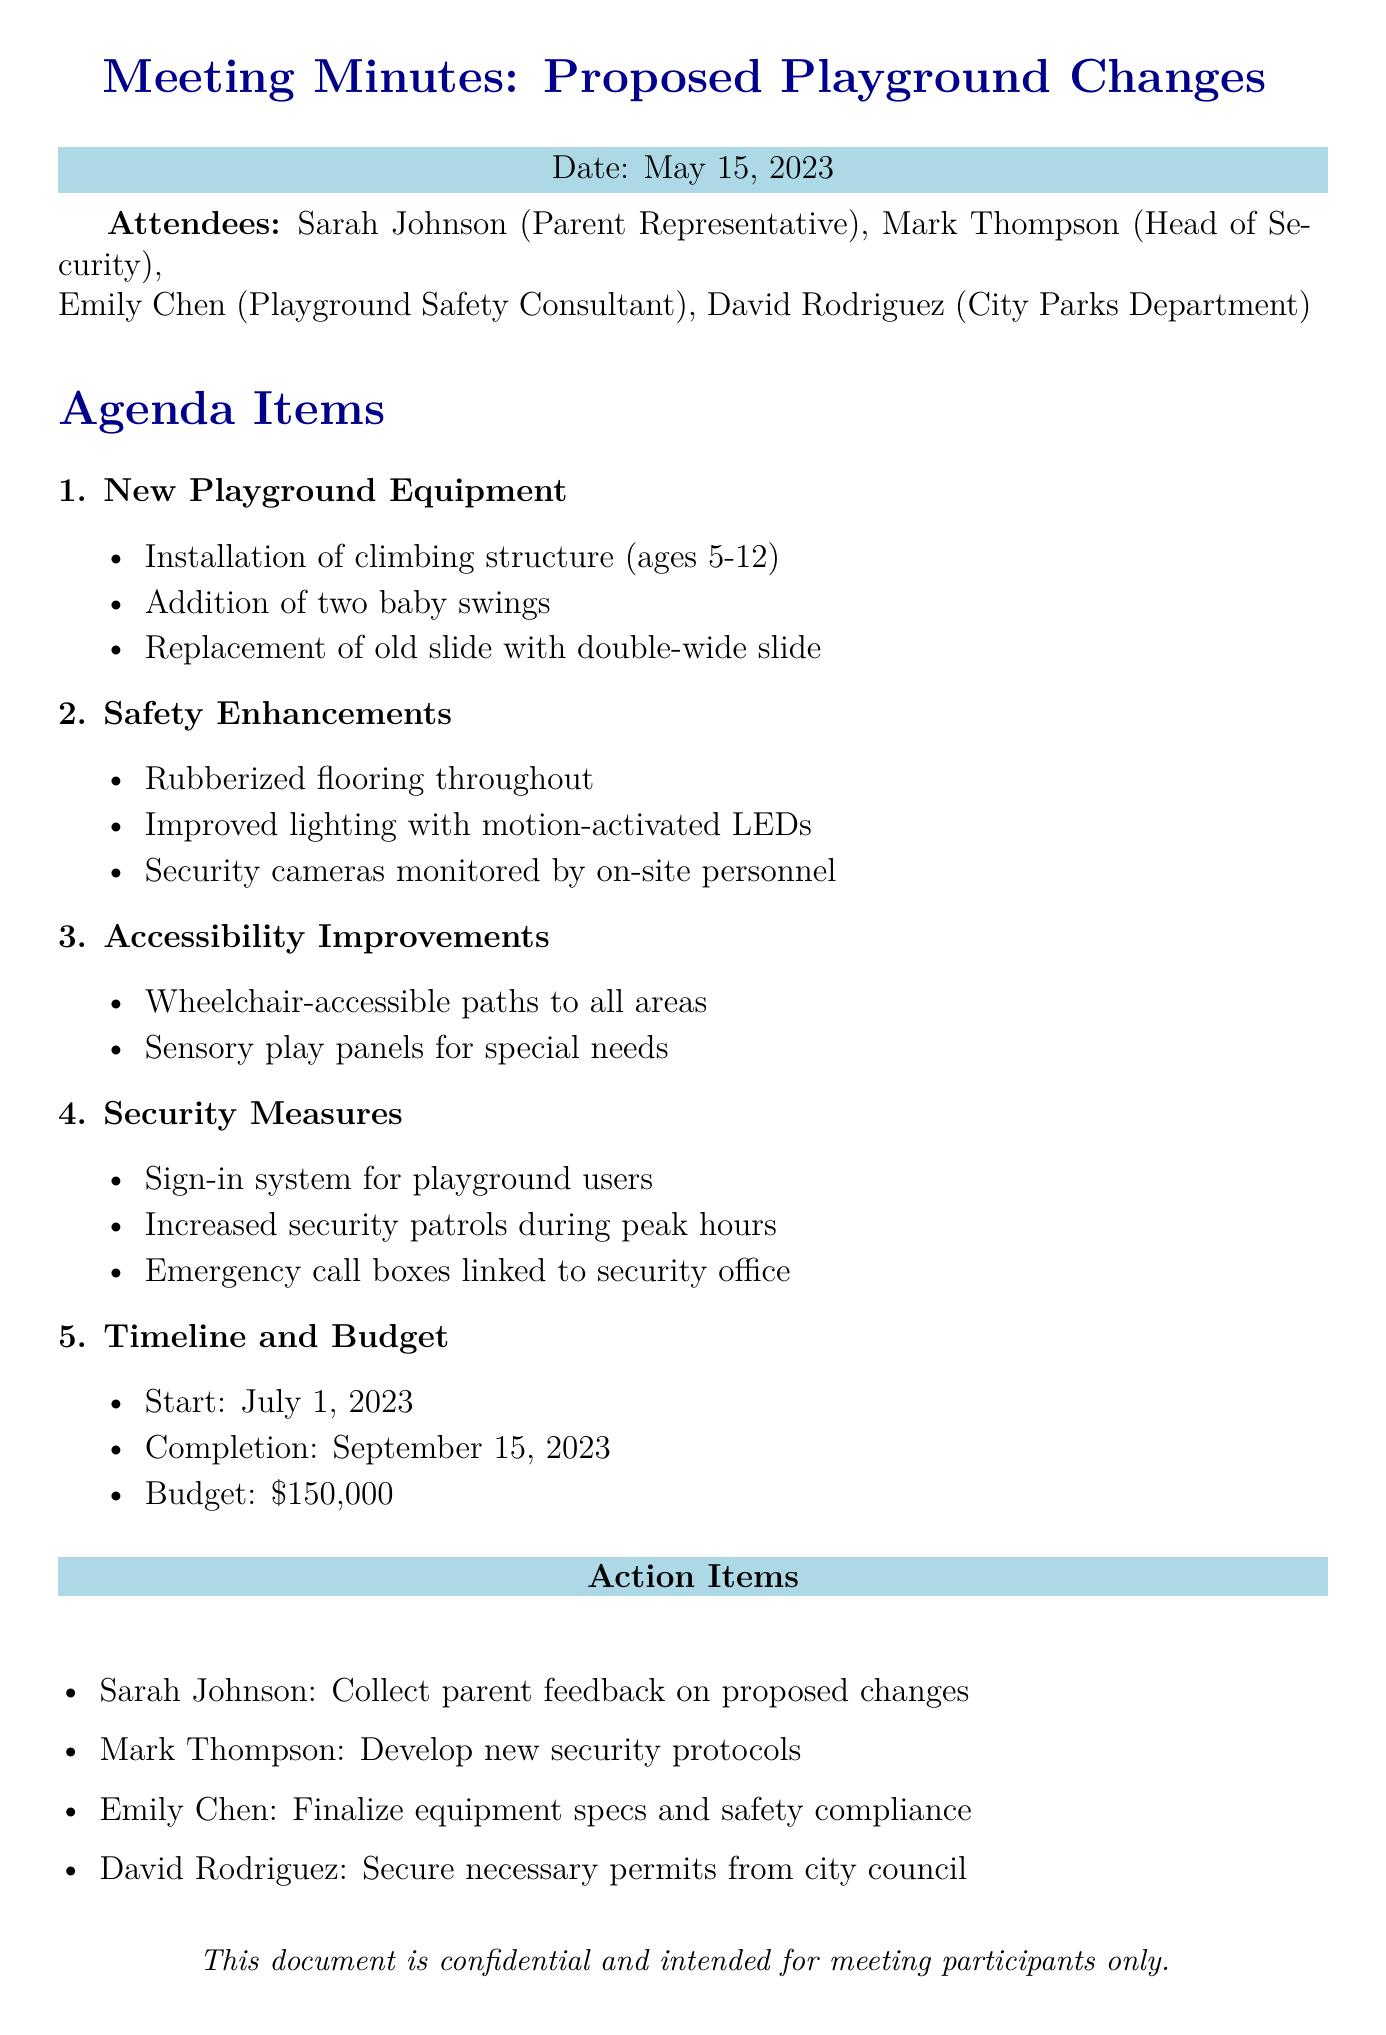what is the date of the meeting? The date of the meeting is mentioned at the beginning of the document.
Answer: May 15, 2023 who is the playground safety consultant? The playground safety consultant is one of the attendees listed in the document.
Answer: Emily Chen what new feature is being added for toddlers? The document lists new features and specifically mentions one for toddlers.
Answer: Two baby swings what safety enhancement is proposed for evening visibility? The safety enhancements section describes measures for improving evening visibility.
Answer: Motion-activated LED lights what is the proposed budget for the playground changes? The budget is outlined in the timeline and budget section of the document.
Answer: $150,000 who is responsible for developing new security protocols? The action items list assigns tasks to specific individuals.
Answer: Mark Thompson how long is the proposed timeline for the project? The document provides start and completion dates which help determine the project duration.
Answer: Approximately 2.5 months what will be installed to help with playground accessibility? The accessibility improvements section specifies features that address accessibility in the playground.
Answer: Wheelchair-accessible paths what is the main purpose of the security measures discussed? The security measures are detailed in a specific agenda item focusing on user safety.
Answer: Enhance safety 